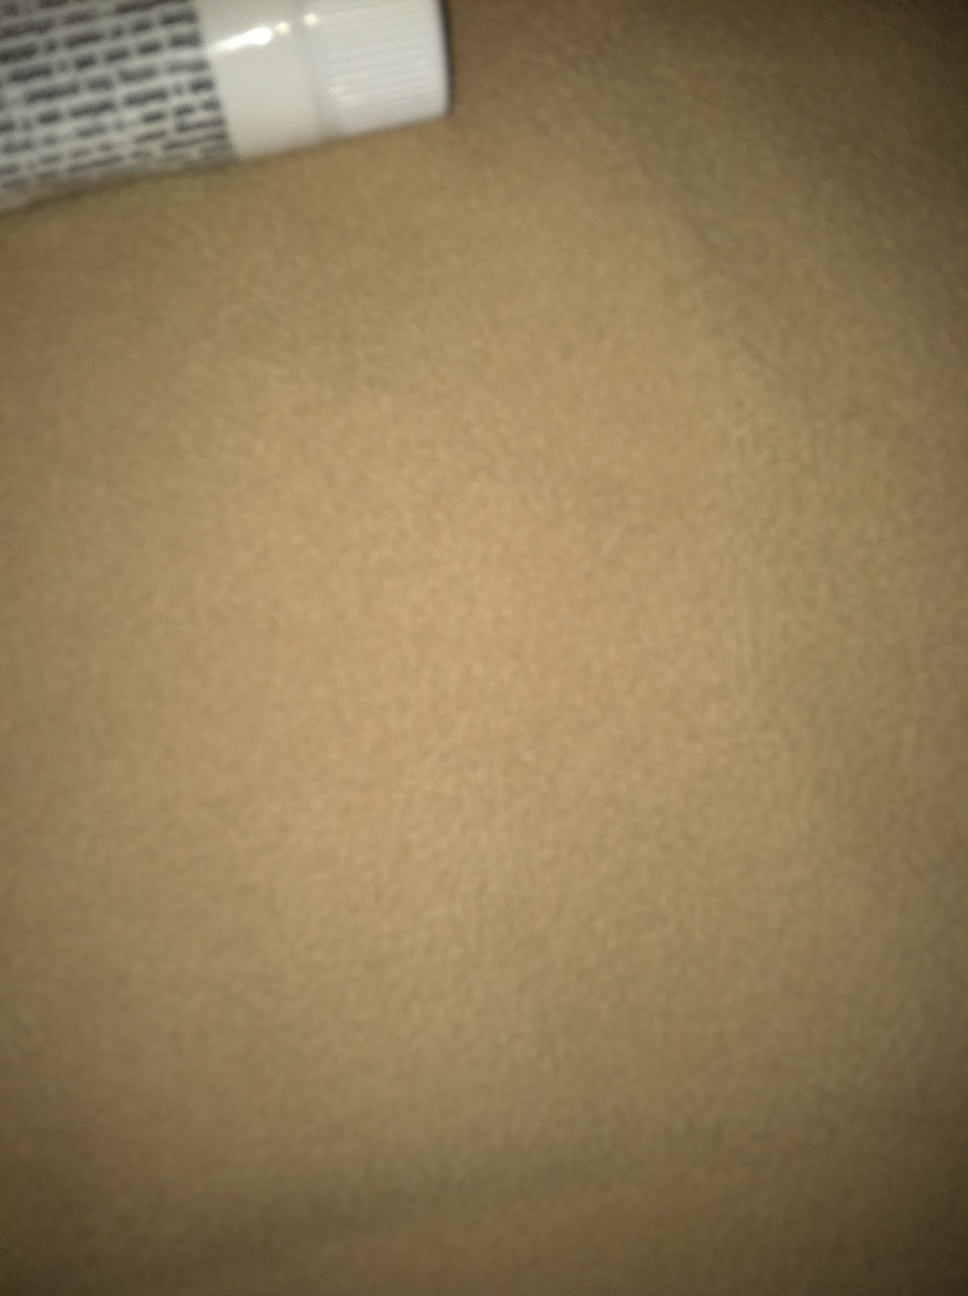Can you tell what kind of product might be in this tube? Due to the angle and the partial view, it's challenging to determine the exact product. The tube suggests that it could contain a form of topical medication, a cosmetic cream, or perhaps a dental product like toothpaste.  Is there any branding or text visible that can help identify the product? The image shows text on the tube, but it is not clearly visible due to the angle and focus. We would need a clearer image to read the branding or product description. 